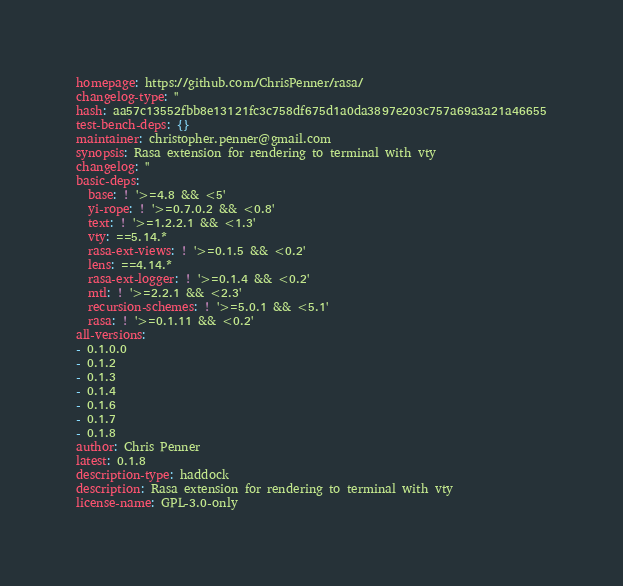Convert code to text. <code><loc_0><loc_0><loc_500><loc_500><_YAML_>homepage: https://github.com/ChrisPenner/rasa/
changelog-type: ''
hash: aa57c13552fbb8e13121fc3c758df675d1a0da3897e203c757a69a3a21a46655
test-bench-deps: {}
maintainer: christopher.penner@gmail.com
synopsis: Rasa extension for rendering to terminal with vty
changelog: ''
basic-deps:
  base: ! '>=4.8 && <5'
  yi-rope: ! '>=0.7.0.2 && <0.8'
  text: ! '>=1.2.2.1 && <1.3'
  vty: ==5.14.*
  rasa-ext-views: ! '>=0.1.5 && <0.2'
  lens: ==4.14.*
  rasa-ext-logger: ! '>=0.1.4 && <0.2'
  mtl: ! '>=2.2.1 && <2.3'
  recursion-schemes: ! '>=5.0.1 && <5.1'
  rasa: ! '>=0.1.11 && <0.2'
all-versions:
- 0.1.0.0
- 0.1.2
- 0.1.3
- 0.1.4
- 0.1.6
- 0.1.7
- 0.1.8
author: Chris Penner
latest: 0.1.8
description-type: haddock
description: Rasa extension for rendering to terminal with vty
license-name: GPL-3.0-only
</code> 